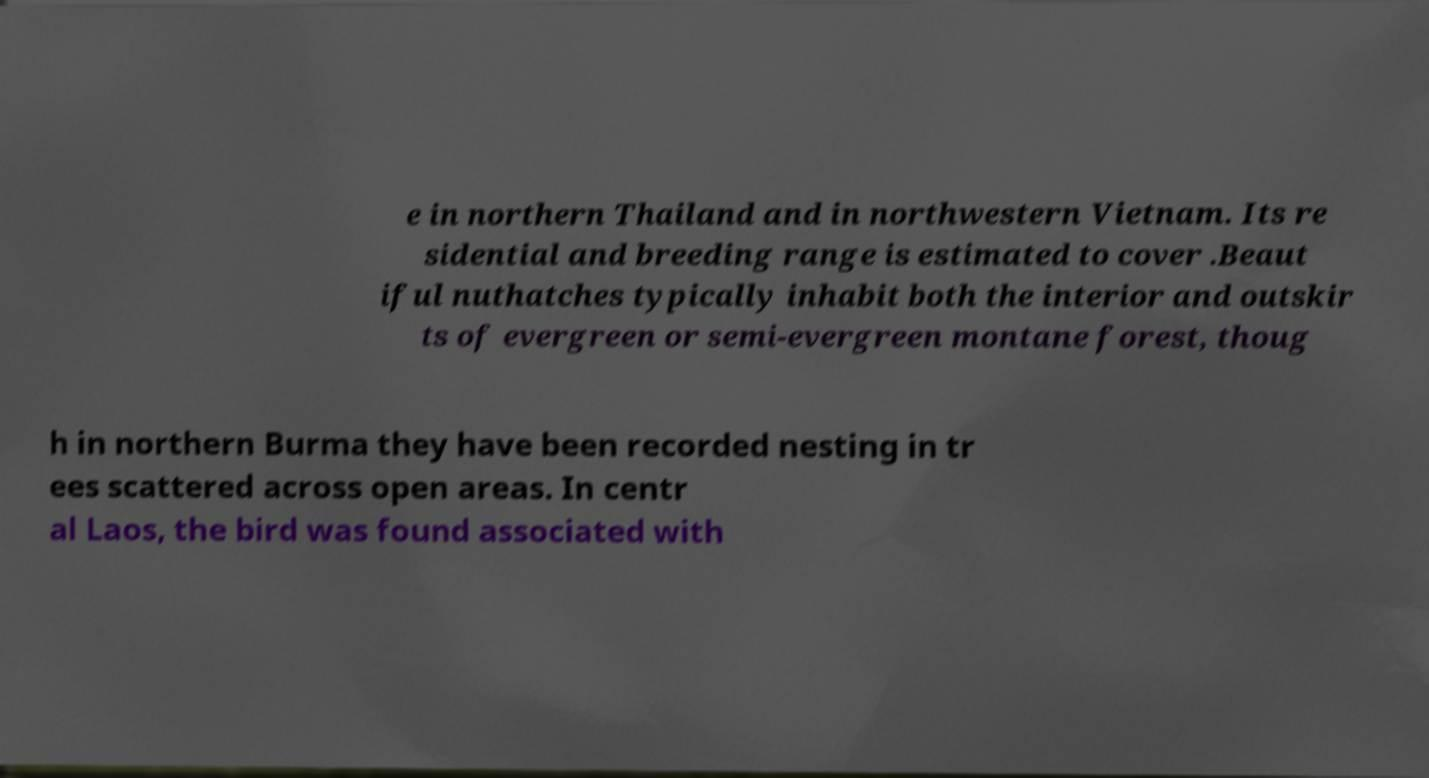Can you accurately transcribe the text from the provided image for me? e in northern Thailand and in northwestern Vietnam. Its re sidential and breeding range is estimated to cover .Beaut iful nuthatches typically inhabit both the interior and outskir ts of evergreen or semi-evergreen montane forest, thoug h in northern Burma they have been recorded nesting in tr ees scattered across open areas. In centr al Laos, the bird was found associated with 